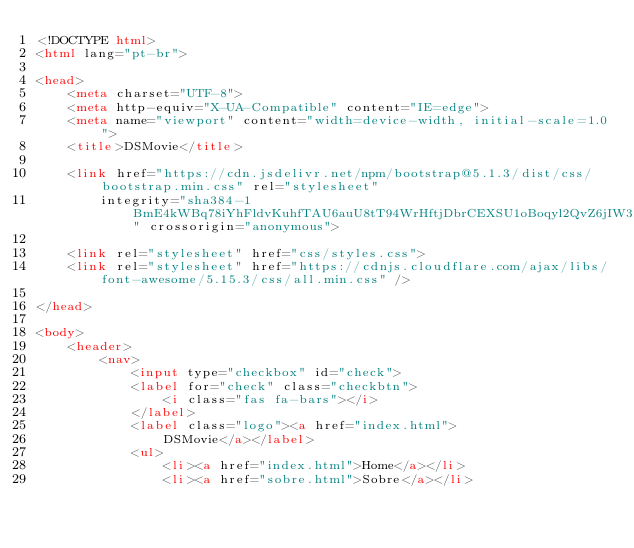<code> <loc_0><loc_0><loc_500><loc_500><_HTML_><!DOCTYPE html>
<html lang="pt-br">

<head>
    <meta charset="UTF-8">
    <meta http-equiv="X-UA-Compatible" content="IE=edge">
    <meta name="viewport" content="width=device-width, initial-scale=1.0">
    <title>DSMovie</title>

    <link href="https://cdn.jsdelivr.net/npm/bootstrap@5.1.3/dist/css/bootstrap.min.css" rel="stylesheet"
        integrity="sha384-1BmE4kWBq78iYhFldvKuhfTAU6auU8tT94WrHftjDbrCEXSU1oBoqyl2QvZ6jIW3" crossorigin="anonymous">

    <link rel="stylesheet" href="css/styles.css">
    <link rel="stylesheet" href="https://cdnjs.cloudflare.com/ajax/libs/font-awesome/5.15.3/css/all.min.css" />

</head>

<body>
    <header>
        <nav>
            <input type="checkbox" id="check">
            <label for="check" class="checkbtn">
                <i class="fas fa-bars"></i>
            </label>
            <label class="logo"><a href="index.html">
                DSMovie</a></label>
            <ul>
                <li><a href="index.html">Home</a></li>
                <li><a href="sobre.html">Sobre</a></li></code> 